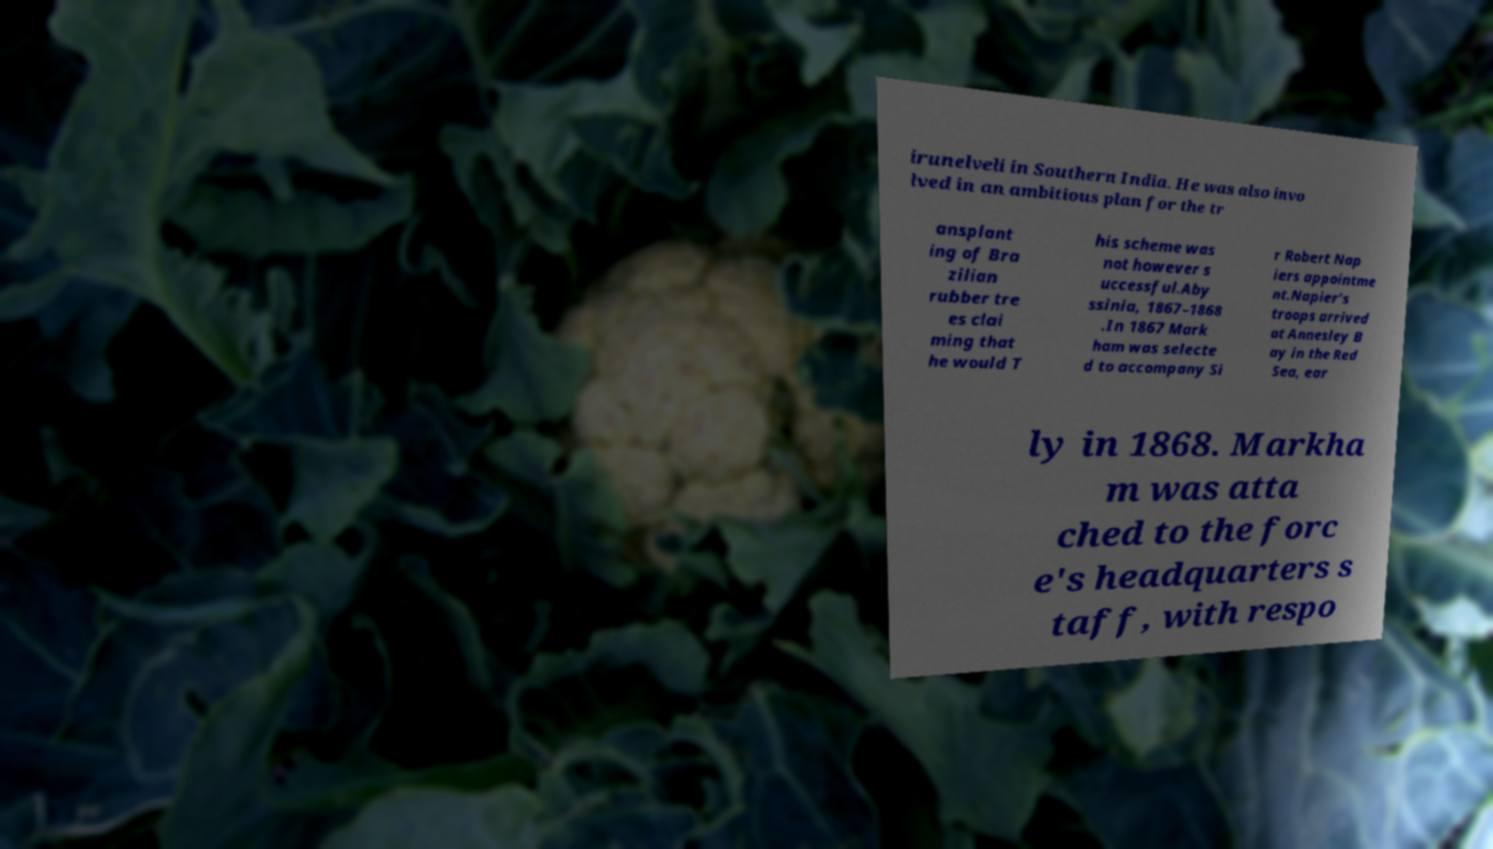For documentation purposes, I need the text within this image transcribed. Could you provide that? irunelveli in Southern India. He was also invo lved in an ambitious plan for the tr ansplant ing of Bra zilian rubber tre es clai ming that he would T his scheme was not however s uccessful.Aby ssinia, 1867–1868 .In 1867 Mark ham was selecte d to accompany Si r Robert Nap iers appointme nt.Napier's troops arrived at Annesley B ay in the Red Sea, ear ly in 1868. Markha m was atta ched to the forc e's headquarters s taff, with respo 